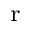Convert formula to latex. <formula><loc_0><loc_0><loc_500><loc_500>_ { r }</formula> 